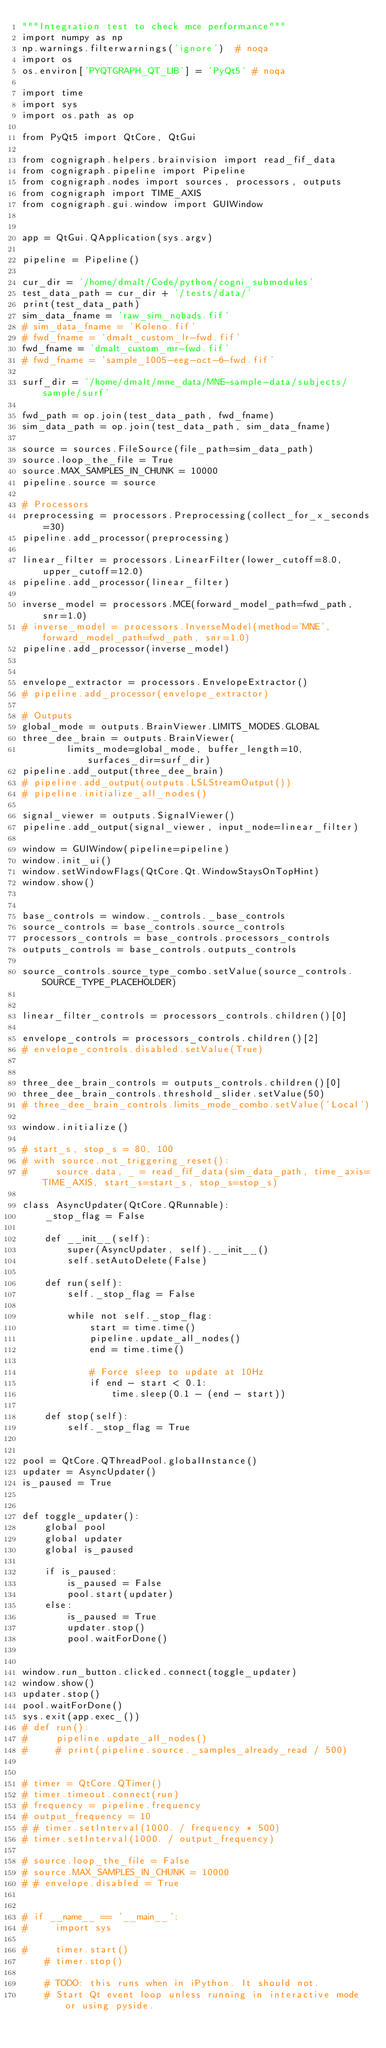<code> <loc_0><loc_0><loc_500><loc_500><_Python_>"""Integration test to check mce performance"""
import numpy as np
np.warnings.filterwarnings('ignore')  # noqa
import os
os.environ['PYQTGRAPH_QT_LIB'] = 'PyQt5' # noqa

import time
import sys
import os.path as op

from PyQt5 import QtCore, QtGui

from cognigraph.helpers.brainvision import read_fif_data
from cognigraph.pipeline import Pipeline
from cognigraph.nodes import sources, processors, outputs
from cognigraph import TIME_AXIS
from cognigraph.gui.window import GUIWindow


app = QtGui.QApplication(sys.argv)

pipeline = Pipeline()

cur_dir = '/home/dmalt/Code/python/cogni_submodules'
test_data_path = cur_dir + '/tests/data/'
print(test_data_path)
sim_data_fname = 'raw_sim_nobads.fif'
# sim_data_fname = 'Koleno.fif'
# fwd_fname = 'dmalt_custom_lr-fwd.fif'
fwd_fname = 'dmalt_custom_mr-fwd.fif'
# fwd_fname = 'sample_1005-eeg-oct-6-fwd.fif'

surf_dir = '/home/dmalt/mne_data/MNE-sample-data/subjects/sample/surf'

fwd_path = op.join(test_data_path, fwd_fname)
sim_data_path = op.join(test_data_path, sim_data_fname)

source = sources.FileSource(file_path=sim_data_path)
source.loop_the_file = True
source.MAX_SAMPLES_IN_CHUNK = 10000
pipeline.source = source

# Processors
preprocessing = processors.Preprocessing(collect_for_x_seconds=30)
pipeline.add_processor(preprocessing)

linear_filter = processors.LinearFilter(lower_cutoff=8.0, upper_cutoff=12.0)
pipeline.add_processor(linear_filter)

inverse_model = processors.MCE(forward_model_path=fwd_path, snr=1.0)
# inverse_model = processors.InverseModel(method='MNE', forward_model_path=fwd_path, snr=1.0)
pipeline.add_processor(inverse_model)


envelope_extractor = processors.EnvelopeExtractor()
# pipeline.add_processor(envelope_extractor)

# Outputs
global_mode = outputs.BrainViewer.LIMITS_MODES.GLOBAL
three_dee_brain = outputs.BrainViewer(
        limits_mode=global_mode, buffer_length=10, surfaces_dir=surf_dir)
pipeline.add_output(three_dee_brain)
# pipeline.add_output(outputs.LSLStreamOutput())
# pipeline.initialize_all_nodes()

signal_viewer = outputs.SignalViewer()
pipeline.add_output(signal_viewer, input_node=linear_filter)

window = GUIWindow(pipeline=pipeline)
window.init_ui()
window.setWindowFlags(QtCore.Qt.WindowStaysOnTopHint)
window.show()


base_controls = window._controls._base_controls
source_controls = base_controls.source_controls
processors_controls = base_controls.processors_controls
outputs_controls = base_controls.outputs_controls

source_controls.source_type_combo.setValue(source_controls.SOURCE_TYPE_PLACEHOLDER)


linear_filter_controls = processors_controls.children()[0]

envelope_controls = processors_controls.children()[2]
# envelope_controls.disabled.setValue(True)


three_dee_brain_controls = outputs_controls.children()[0]
three_dee_brain_controls.threshold_slider.setValue(50)
# three_dee_brain_controls.limits_mode_combo.setValue('Local')

window.initialize()

# start_s, stop_s = 80, 100
# with source.not_triggering_reset():
#     source.data, _ = read_fif_data(sim_data_path, time_axis=TIME_AXIS, start_s=start_s, stop_s=stop_s)

class AsyncUpdater(QtCore.QRunnable):
    _stop_flag = False

    def __init__(self):
        super(AsyncUpdater, self).__init__()
        self.setAutoDelete(False)

    def run(self):
        self._stop_flag = False

        while not self._stop_flag:
            start = time.time()
            pipeline.update_all_nodes()
            end = time.time()

            # Force sleep to update at 10Hz
            if end - start < 0.1:
                time.sleep(0.1 - (end - start))

    def stop(self):
        self._stop_flag = True


pool = QtCore.QThreadPool.globalInstance()
updater = AsyncUpdater()
is_paused = True


def toggle_updater():
    global pool
    global updater
    global is_paused

    if is_paused:
        is_paused = False
        pool.start(updater)
    else:
        is_paused = True
        updater.stop()
        pool.waitForDone()


window.run_button.clicked.connect(toggle_updater)
window.show()
updater.stop()
pool.waitForDone()
sys.exit(app.exec_())
# def run():
#     pipeline.update_all_nodes()
#     # print(pipeline.source._samples_already_read / 500)


# timer = QtCore.QTimer()
# timer.timeout.connect(run)
# frequency = pipeline.frequency
# output_frequency = 10
# # timer.setInterval(1000. / frequency * 500)
# timer.setInterval(1000. / output_frequency)

# source.loop_the_file = False
# source.MAX_SAMPLES_IN_CHUNK = 10000
# # envelope.disabled = True


# if __name__ == '__main__':
#     import sys

#     timer.start()
    # timer.stop()

    # TODO: this runs when in iPython. It should not.
    # Start Qt event loop unless running in interactive mode or using pyside.</code> 